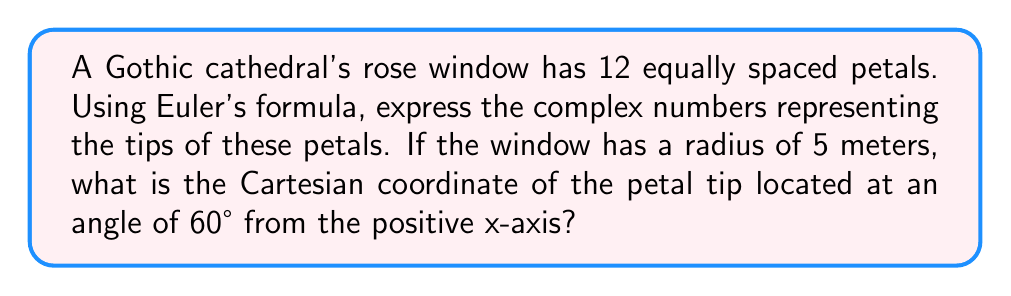Provide a solution to this math problem. Let's approach this step-by-step:

1) Euler's formula states that for any real number $\theta$:

   $$e^{i\theta} = \cos\theta + i\sin\theta$$

2) In a 12-petal rose window, the petals are equally spaced at angles of $\frac{2\pi}{12} = \frac{\pi}{6}$ radians apart.

3) We can represent the tips of the petals as complex numbers using the formula:

   $$z_k = 5e^{i\frac{2\pi k}{12}}, \quad k = 0, 1, 2, ..., 11$$

   Where 5 is the radius of the window.

4) For the petal at 60°, we have $\frac{\pi}{3}$ radians. This corresponds to $k = 2$ in our formula:

   $$z_2 = 5e^{i\frac{2\pi \cdot 2}{12}} = 5e^{i\frac{\pi}{3}}$$

5) Using Euler's formula:

   $$z_2 = 5(\cos\frac{\pi}{3} + i\sin\frac{\pi}{3})$$

6) We know that $\cos\frac{\pi}{3} = \frac{1}{2}$ and $\sin\frac{\pi}{3} = \frac{\sqrt{3}}{2}$

7) Substituting these values:

   $$z_2 = 5(\frac{1}{2} + i\frac{\sqrt{3}}{2})$$

8) Simplifying:

   $$z_2 = \frac{5}{2} + i\frac{5\sqrt{3}}{2}$$

9) The Cartesian coordinate is the real and imaginary parts of this complex number:

   $(\frac{5}{2}, \frac{5\sqrt{3}}{2})$
Answer: The Cartesian coordinate of the petal tip at 60° from the positive x-axis is $(\frac{5}{2}, \frac{5\sqrt{3}}{2})$ meters. 